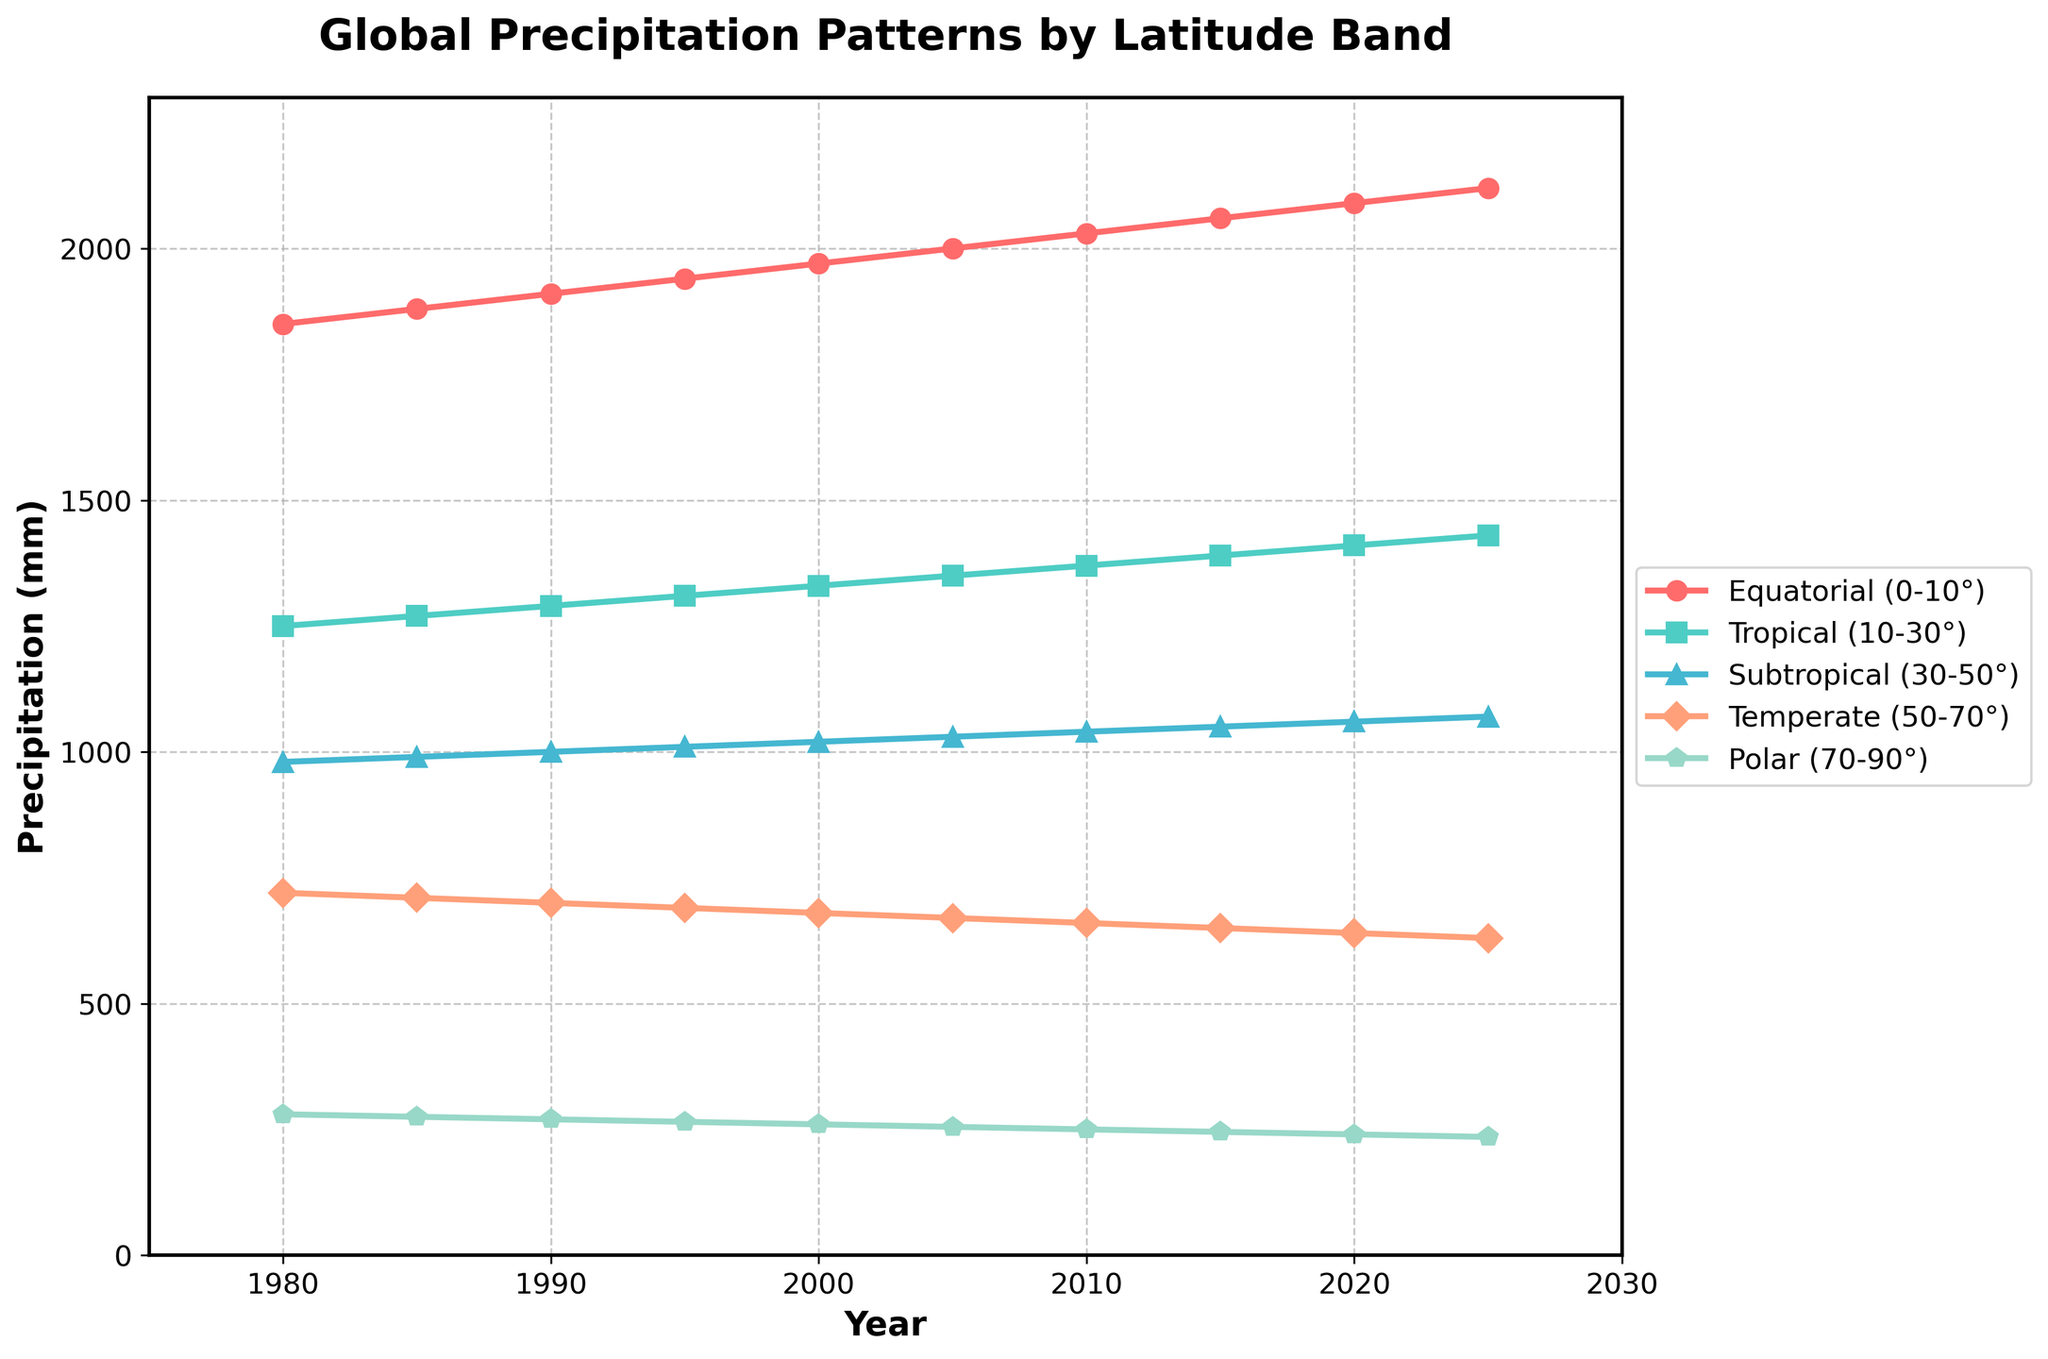What is the general trend in precipitation for the Equatorial (0-10°) latitude band from 1980 to 2025? The Equatorial band shows a consistent upward trend in precipitation from 1980 to 2025. This can be observed by following the line associated with the Equatorial band, which continually points upwards across the years.
Answer: Increasing Which latitude band had the highest precipitation in 2020? In 2020, the line representing the Equatorial (0-10°) band is at the highest point among all latitude bands on the graph. This is evident because the Equatorial line is at the topmost position relative to the other bands in that year's vertical section.
Answer: Equatorial (0-10°) How does the precipitation in the Polar (70-90°) latitude band in 2000 compare to that in 2025? To compare these values, look at the points for the Polar band in 2000 and 2025. In 2000, the Polar precipitation is 260 mm, while in 2025, it drops to 235 mm. Thus, precipitation decreased by 25 mm over this period.
Answer: Decreased by 25 mm Calculate the average precipitation in the Subtropical (30-50°) latitude band for the years 1980, 2000, and 2020. The precipitation values for the Subtropical band in these years are 980 mm, 1020 mm, and 1060 mm respectively. Adding them gives 980 + 1020 + 1060 = 3060. Dividing by 3, the average is 3060 / 3 = 1020 mm.
Answer: 1020 mm What is the difference in precipitation between the Tropical (10-30°) and Temperate (50-70°) bands in 2010? In 2010, the Tropical band has a precipitation value of 1370 mm and the Temperate band has 660 mm. The difference is 1370 - 660 = 710 mm.
Answer: 710 mm In which year did the Subtropical (30-50°) band first exceed 1000 mm of precipitation? The Subtropical band exceeds 1000 mm starting in 1990, indicated by the corresponding point being above 1000 mm on the y-axis for that year.
Answer: 1990 Among the presented latitude bands, which one shows the most stable precipitation trends over the years displayed? The Polar (70-90°) band shows the most stable trend, as its line remains relatively horizontal with only a slight downward slope. This indicates stability in its precipitation pattern.
Answer: Polar (70-90°) When was the precipitation in the Temperate (50-70°) latitude band the lowest within the given dataset? The lowest observed precipitation for the Temperate band occurs in 2025, at 630 mm. This is the smallest value on the graph for this latitude over the years.
Answer: 2025 What is the combined precipitation of the Equatorial (0-10°) and Polar (70-90°) bands in 2005? In 2005, the Equatorial band has 2000 mm and the Polar band has 255 mm. Summing these gives 2000 + 255 = 2255 mm.
Answer: 2255 mm 